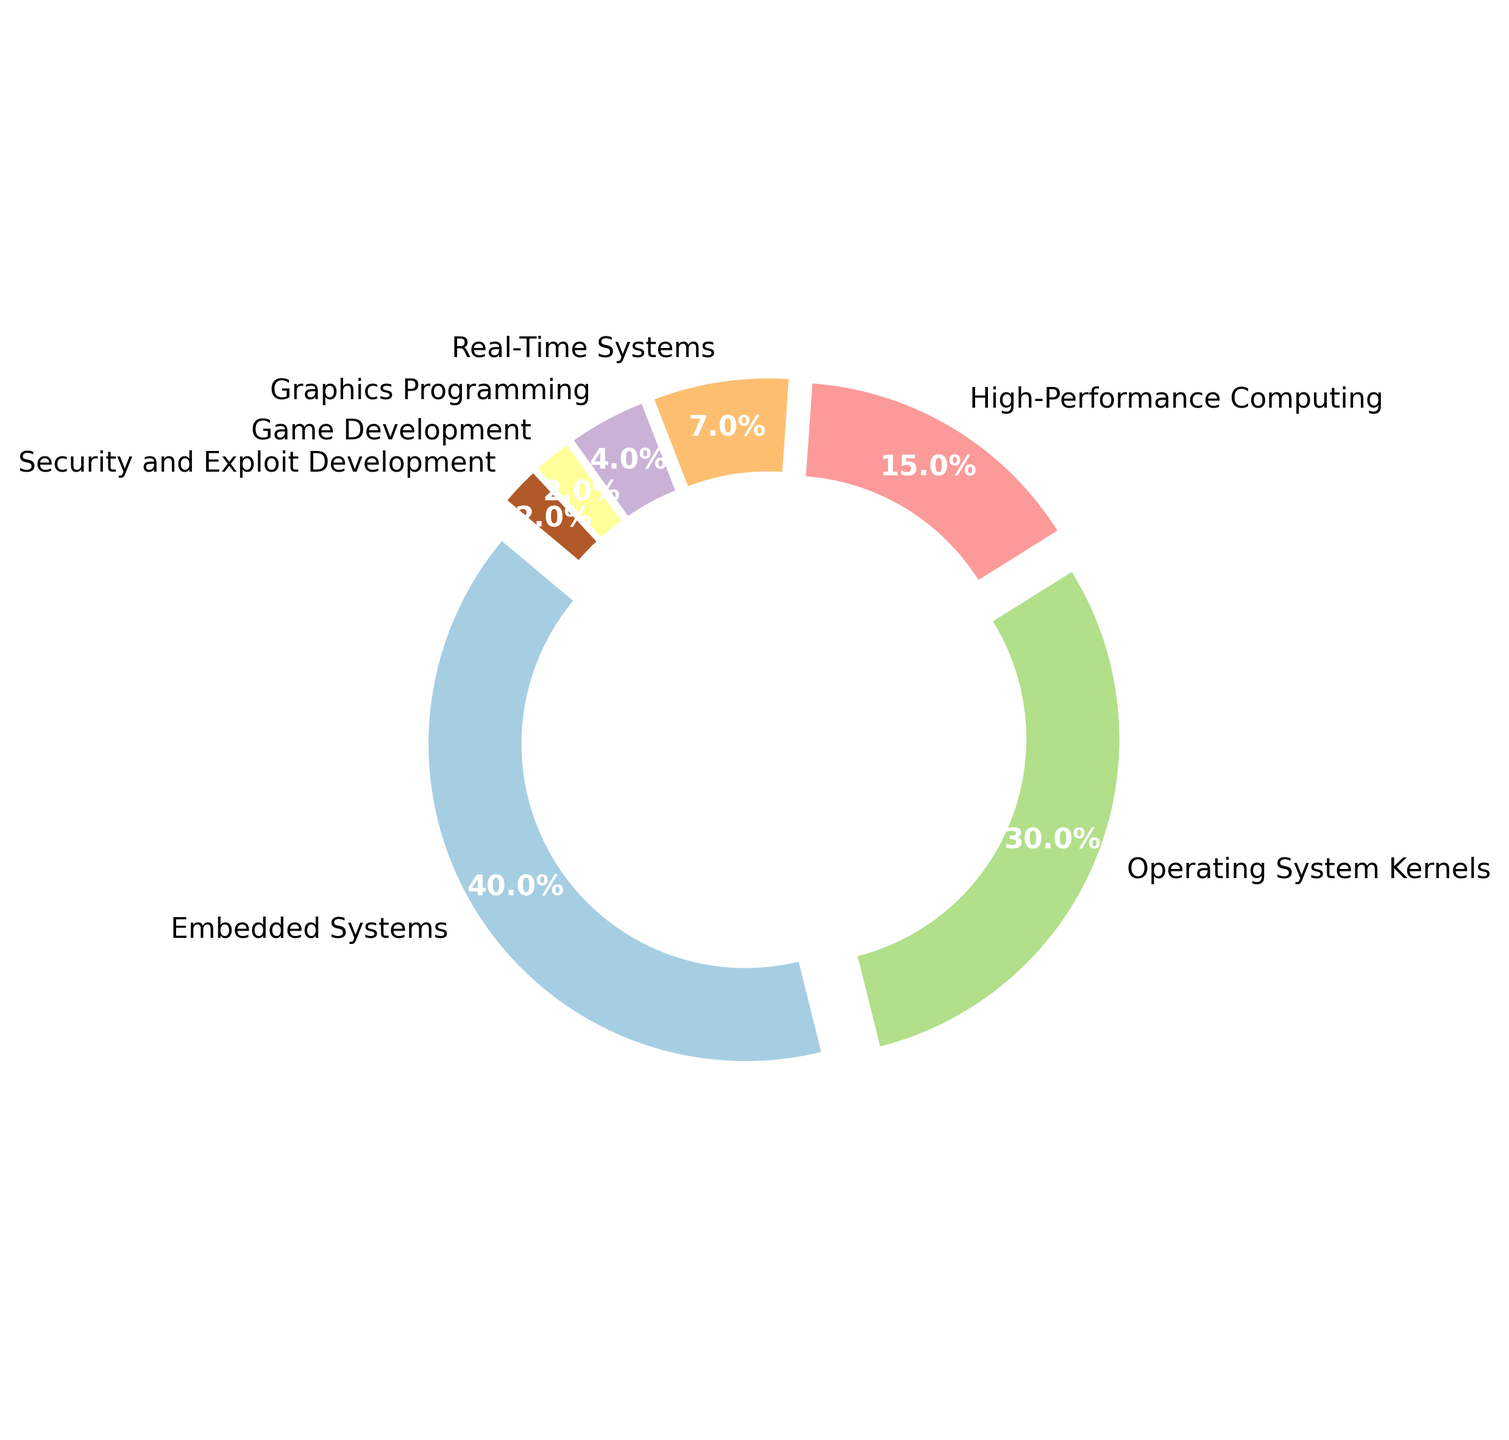What's the total percentage of assembly code usage in Embedded Systems, Operating System Kernels, and Real-Time Systems? Add the percentages: Embedded Systems (40%) + Operating System Kernels (30%) + Real-Time Systems (7%) = 40 + 30 + 7 = 77
Answer: 77% Which category has the highest assembly code usage? The largest segment in the ring chart represents Embedded Systems with 40% usage.
Answer: Embedded Systems What is the difference in assembly code usage between High-Performance Computing and Graphics Programming? Subtract the percentage for Graphics Programming (4%) from High-Performance Computing (15%): 15 - 4 = 11
Answer: 11% Is the assembly code usage in Embedded Systems greater than the combined usage in Game Development and Security and Exploit Development? Compare Embedded Systems (40%) with the sum of Game Development (2%) + Security and Exploit Development (2%): 40 > (2 + 2) = 40 > 4
Answer: Yes Which category has the smallest amount of assembly code usage? The smallest segment in the ring chart represents both Game Development and Security and Exploit Development, each with 2% usage.
Answer: Game Development and Security and Exploit Development Among Operating System Kernels, Real-Time Systems, and Game Development, which one uses the most assembly code? Compare Operating System Kernels (30%), Real-Time Systems (7%), and Game Development (2%): 30 > 7 > 2.
Answer: Operating System Kernels What's the average assembly code usage percentage of High-Performance Computing, Real-Time Systems, and Graphics Programming? Add the percentages: 15% (High-Performance Computing) + 7% (Real-Time Systems) + 4% (Graphics Programming) = 26; then divide by number of categories (3): 26/3 ≈ 8.67
Answer: 8.67 If assembly code use in Real-Time Systems increased by 3%, what would be the new percentage for Real-Time Systems? Add the increase to the existing percentage: 7% + 3% = 10%
Answer: 10% Which category contributes to more assembly code usage, Graphics Programming or Game Development? Compare the percentages: 4% (Graphics Programming) vs. 2% (Game Development).
Answer: Graphics Programming If the percentage of Operating System Kernels doubled, what would be the new total percentage of all categories together? Operating System Kernels would become 30% * 2 = 60%. Add to the original combined percentage (100 - 30 = 70% + 60%): 70 + 60 = 130
Answer: 130 